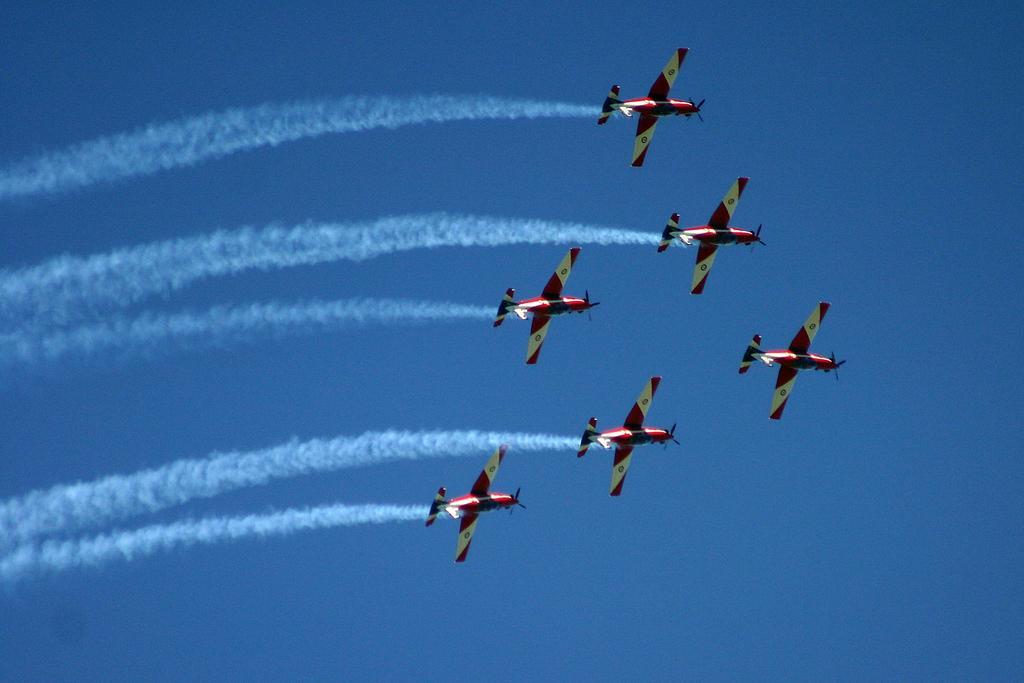In one or two sentences, can you explain what this image depicts? This image is taken outdoors. In the background there is the sky. In the middle of the image a few airplanes are flying in the sky and there is smoke. 